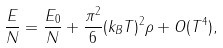Convert formula to latex. <formula><loc_0><loc_0><loc_500><loc_500>\frac { E } { N } = \frac { E _ { 0 } } { N } + \frac { \pi ^ { 2 } } { 6 } ( k _ { B } T ) ^ { 2 } \rho + O ( T ^ { 4 } ) ,</formula> 